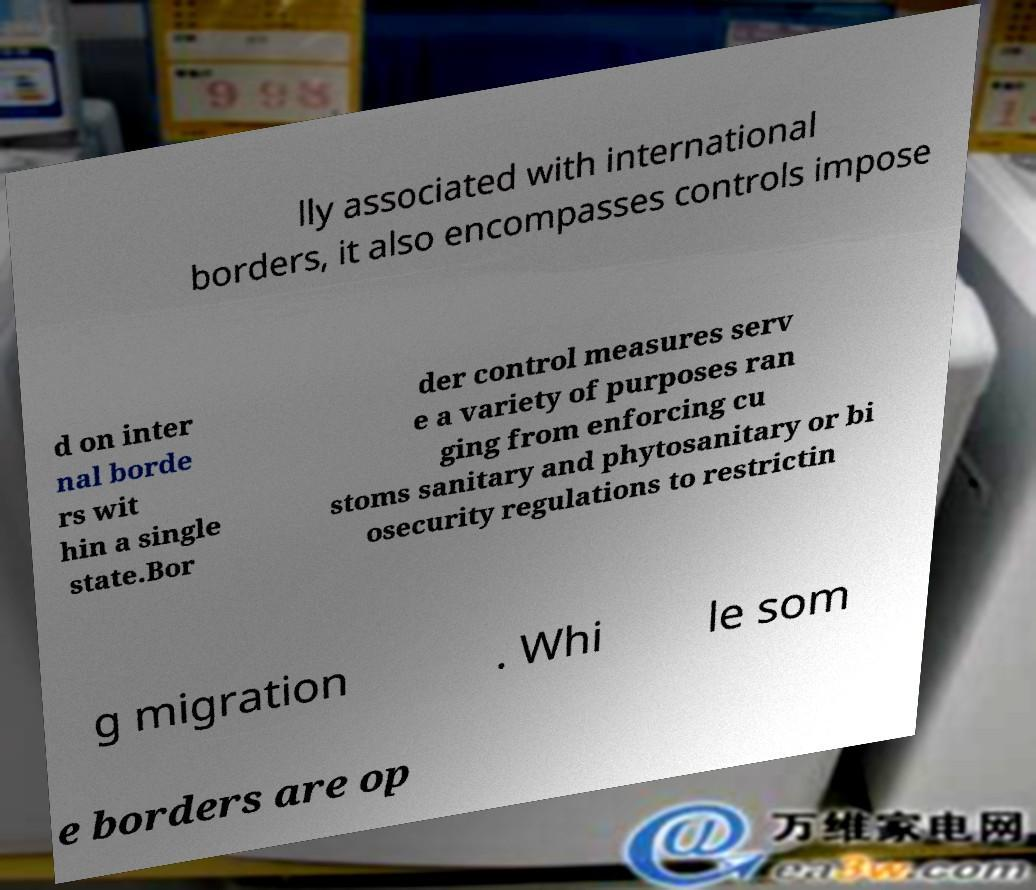Please identify and transcribe the text found in this image. lly associated with international borders, it also encompasses controls impose d on inter nal borde rs wit hin a single state.Bor der control measures serv e a variety of purposes ran ging from enforcing cu stoms sanitary and phytosanitary or bi osecurity regulations to restrictin g migration . Whi le som e borders are op 